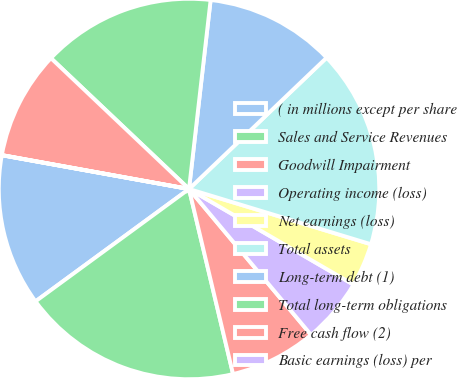Convert chart to OTSL. <chart><loc_0><loc_0><loc_500><loc_500><pie_chart><fcel>( in millions except per share<fcel>Sales and Service Revenues<fcel>Goodwill Impairment<fcel>Operating income (loss)<fcel>Net earnings (loss)<fcel>Total assets<fcel>Long-term debt (1)<fcel>Total long-term obligations<fcel>Free cash flow (2)<fcel>Basic earnings (loss) per<nl><fcel>12.9%<fcel>18.66%<fcel>7.37%<fcel>5.53%<fcel>3.69%<fcel>16.82%<fcel>11.06%<fcel>14.74%<fcel>9.22%<fcel>0.01%<nl></chart> 